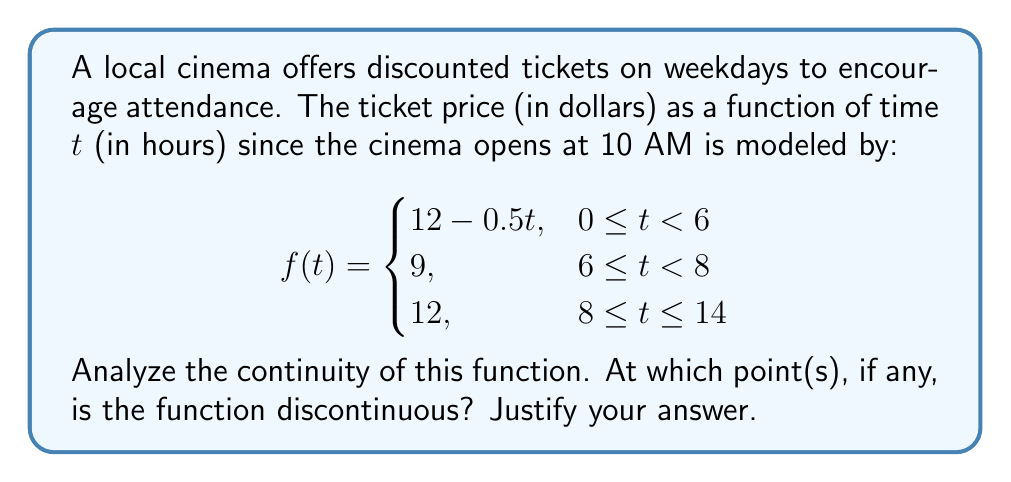Teach me how to tackle this problem. To analyze the continuity of this piecewise function, we need to check for continuity at the transition points between the different pieces of the function. These points are at $t=6$ and $t=8$.

1. Continuity at $t=6$:
   - Left-hand limit: $\lim_{t \to 6^-} f(t) = 12 - 0.5(6) = 9$
   - Right-hand limit: $\lim_{t \to 6^+} f(t) = 9$
   - Function value: $f(6) = 9$

   All three values are equal, so the function is continuous at $t=6$.

2. Continuity at $t=8$:
   - Left-hand limit: $\lim_{t \to 8^-} f(t) = 9$
   - Right-hand limit: $\lim_{t \to 8^+} f(t) = 12$
   - Function value: $f(8) = 12$

   The left-hand limit does not equal the right-hand limit or the function value, so the function is discontinuous at $t=8$.

3. Continuity within each piece:
   - For $0 \leq t < 6$: $f(t) = 12 - 0.5t$ is a linear function, which is continuous.
   - For $6 \leq t < 8$ and $8 \leq t \leq 14$: $f(t)$ is constant, which is continuous.

Therefore, the function is continuous everywhere except at $t=8$, where it has a jump discontinuity.
Answer: The function is discontinuous at $t=8$. 